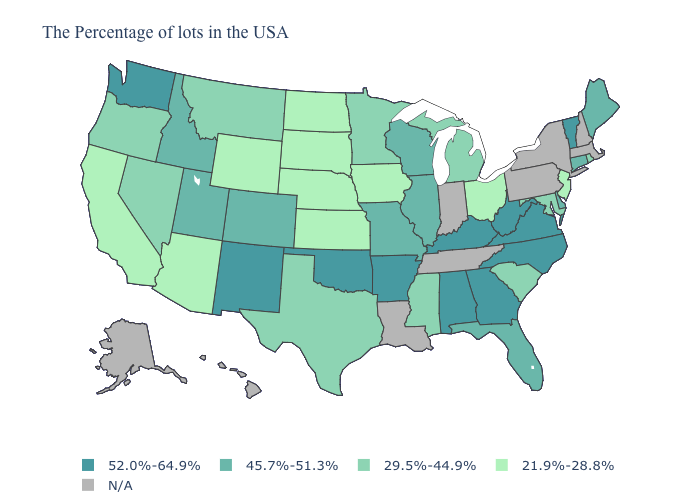How many symbols are there in the legend?
Write a very short answer. 5. What is the value of Iowa?
Write a very short answer. 21.9%-28.8%. What is the value of Mississippi?
Write a very short answer. 29.5%-44.9%. Among the states that border Rhode Island , which have the highest value?
Be succinct. Connecticut. How many symbols are there in the legend?
Keep it brief. 5. What is the highest value in the West ?
Give a very brief answer. 52.0%-64.9%. Among the states that border Arkansas , does Texas have the lowest value?
Quick response, please. Yes. Name the states that have a value in the range 21.9%-28.8%?
Be succinct. New Jersey, Ohio, Iowa, Kansas, Nebraska, South Dakota, North Dakota, Wyoming, Arizona, California. Which states have the lowest value in the USA?
Answer briefly. New Jersey, Ohio, Iowa, Kansas, Nebraska, South Dakota, North Dakota, Wyoming, Arizona, California. Does Wyoming have the lowest value in the USA?
Quick response, please. Yes. Among the states that border Colorado , which have the lowest value?
Write a very short answer. Kansas, Nebraska, Wyoming, Arizona. Among the states that border Illinois , does Kentucky have the highest value?
Write a very short answer. Yes. Among the states that border Illinois , does Missouri have the lowest value?
Concise answer only. No. What is the value of Delaware?
Answer briefly. 45.7%-51.3%. 